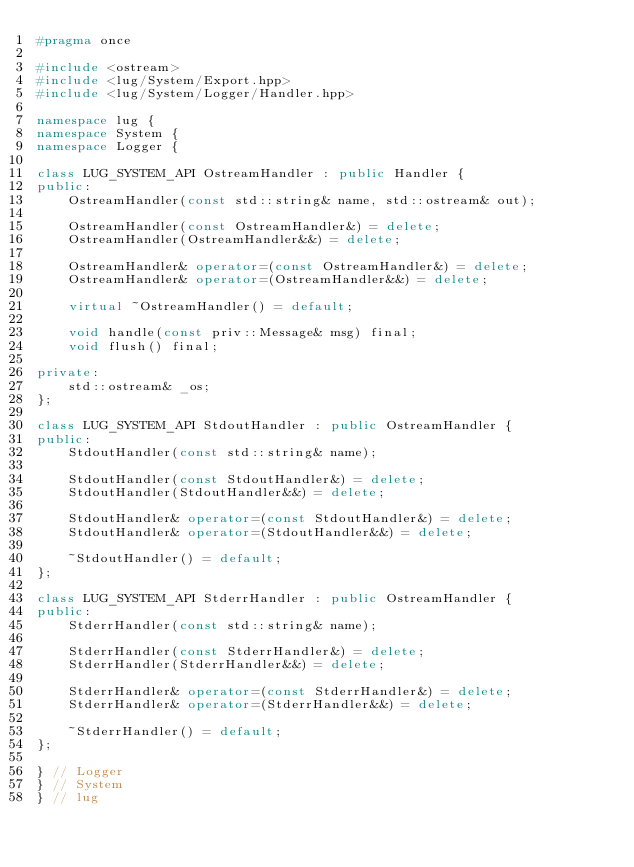<code> <loc_0><loc_0><loc_500><loc_500><_C++_>#pragma once

#include <ostream>
#include <lug/System/Export.hpp>
#include <lug/System/Logger/Handler.hpp>

namespace lug {
namespace System {
namespace Logger {

class LUG_SYSTEM_API OstreamHandler : public Handler {
public:
    OstreamHandler(const std::string& name, std::ostream& out);

    OstreamHandler(const OstreamHandler&) = delete;
    OstreamHandler(OstreamHandler&&) = delete;

    OstreamHandler& operator=(const OstreamHandler&) = delete;
    OstreamHandler& operator=(OstreamHandler&&) = delete;

    virtual ~OstreamHandler() = default;

    void handle(const priv::Message& msg) final;
    void flush() final;

private:
    std::ostream& _os;
};

class LUG_SYSTEM_API StdoutHandler : public OstreamHandler {
public:
    StdoutHandler(const std::string& name);

    StdoutHandler(const StdoutHandler&) = delete;
    StdoutHandler(StdoutHandler&&) = delete;

    StdoutHandler& operator=(const StdoutHandler&) = delete;
    StdoutHandler& operator=(StdoutHandler&&) = delete;

    ~StdoutHandler() = default;
};

class LUG_SYSTEM_API StderrHandler : public OstreamHandler {
public:
    StderrHandler(const std::string& name);

    StderrHandler(const StderrHandler&) = delete;
    StderrHandler(StderrHandler&&) = delete;

    StderrHandler& operator=(const StderrHandler&) = delete;
    StderrHandler& operator=(StderrHandler&&) = delete;

    ~StderrHandler() = default;
};

} // Logger
} // System
} // lug
</code> 